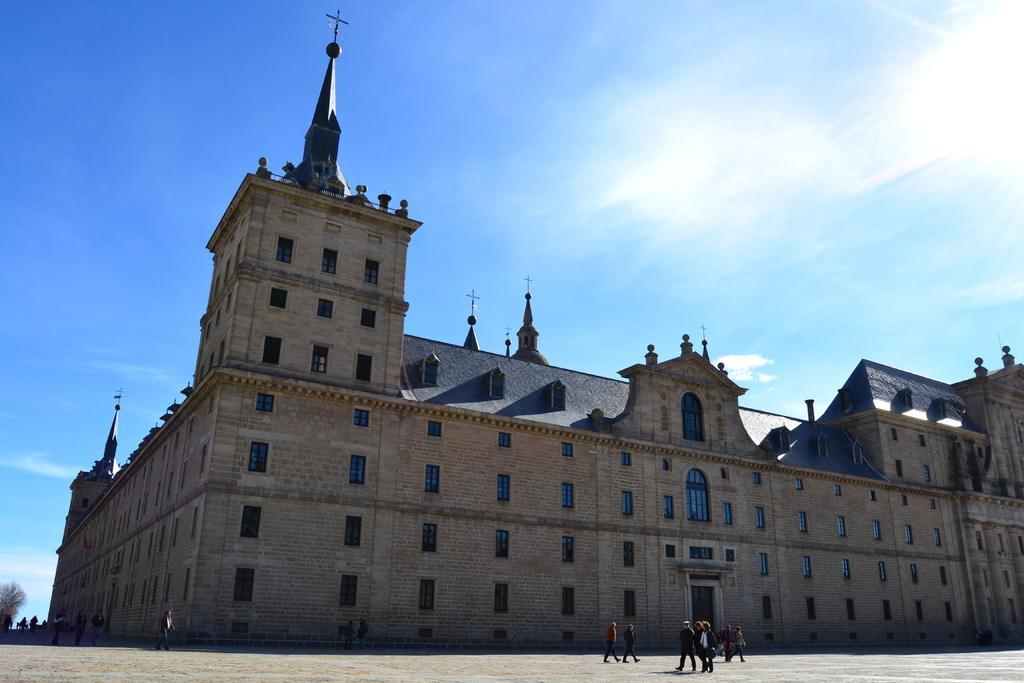Can you describe this image briefly? In the center of the image there is a building. In front of the building there are people walking on the road. In the background of the image there are trees and sky. 